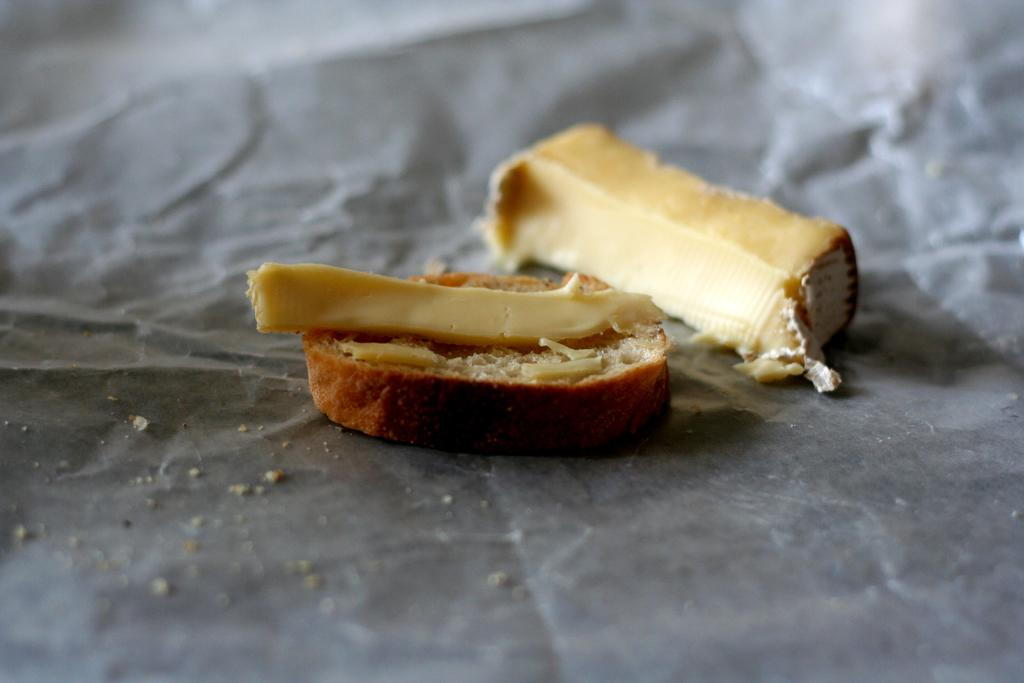What type of food can be seen in the image? There is a slice of cheese in the image. What is the cheese placed on? The slice of cheese is placed on a slice of bread. How many bikes are parked next to the cheese in the image? There are no bikes present in the image; it only features a slice of cheese on a slice of bread. 